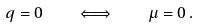Convert formula to latex. <formula><loc_0><loc_0><loc_500><loc_500>q = 0 \quad \Longleftrightarrow \quad \mu = 0 \, .</formula> 